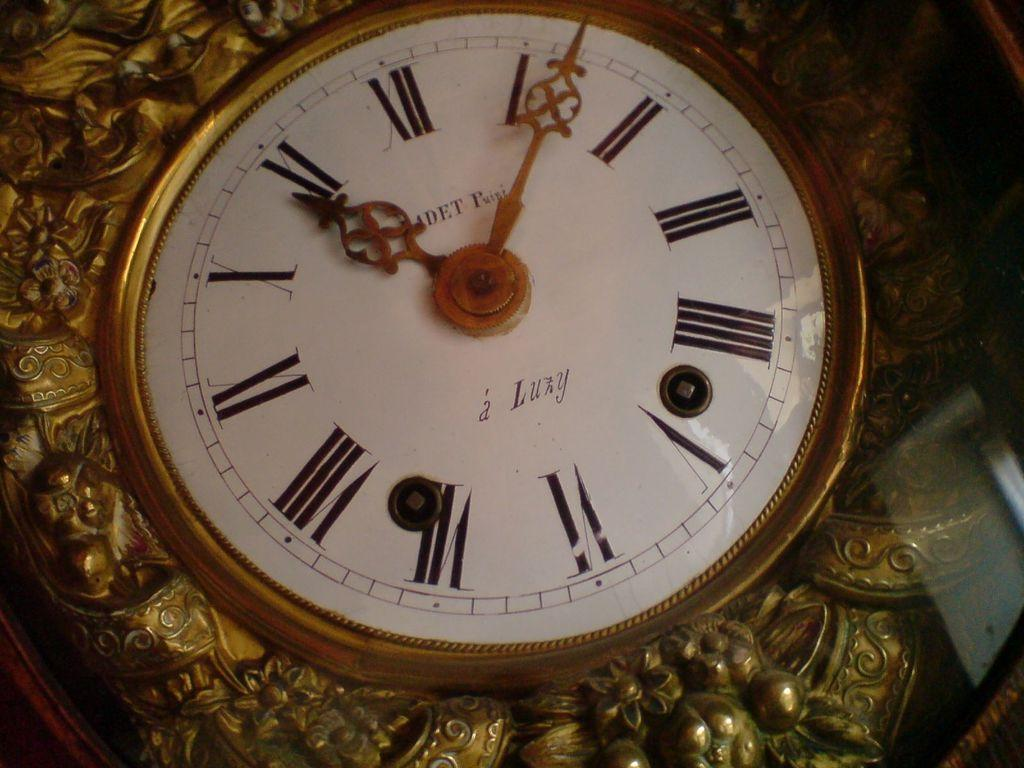<image>
Describe the image concisely. A clock says a Luzy on the bottom part of the face. 